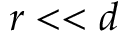Convert formula to latex. <formula><loc_0><loc_0><loc_500><loc_500>r < < d</formula> 